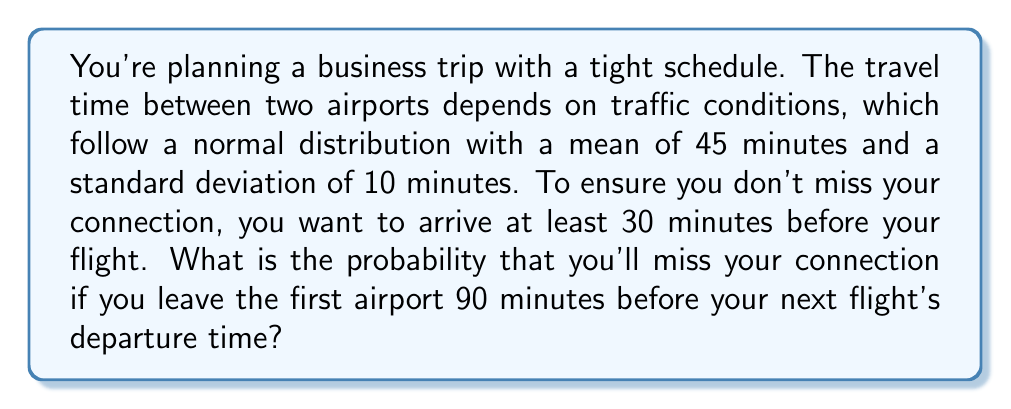Teach me how to tackle this problem. Let's approach this step-by-step:

1) We're dealing with a normal distribution where:
   $\mu = 45$ minutes (mean travel time)
   $\sigma = 10$ minutes (standard deviation)

2) We need to find the probability of the travel time being more than 60 minutes (90 minutes minus the 30-minute buffer).

3) To do this, we need to calculate the z-score for 60 minutes:

   $$z = \frac{x - \mu}{\sigma} = \frac{60 - 45}{10} = 1.5$$

4) Now, we need to find the probability of z > 1.5 in a standard normal distribution.

5) Using a standard normal table or calculator, we can find that:
   P(z > 1.5) ≈ 0.0668

6) This means the probability of the travel time exceeding 60 minutes is about 0.0668 or 6.68%.

7) Therefore, the probability of missing the connection is 6.68%.
Answer: 0.0668 or 6.68% 